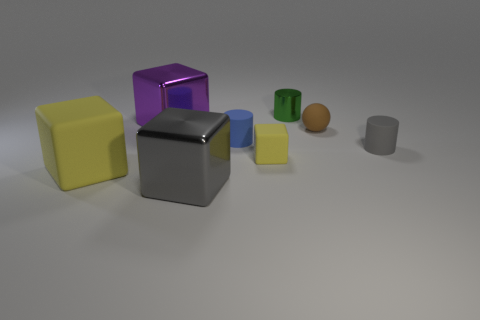Are there any gray metal cubes right of the tiny blue rubber cylinder?
Your answer should be compact. No. What size is the blue matte thing that is the same shape as the small green shiny thing?
Give a very brief answer. Small. There is a small rubber cube; is its color the same as the shiny block in front of the large yellow matte object?
Ensure brevity in your answer.  No. Do the large rubber block and the tiny rubber ball have the same color?
Ensure brevity in your answer.  No. Is the number of small gray rubber things less than the number of large blocks?
Your answer should be compact. Yes. What number of other objects are the same color as the large matte block?
Your answer should be very brief. 1. What number of big red rubber things are there?
Ensure brevity in your answer.  0. Is the number of purple things right of the blue matte cylinder less than the number of tiny gray matte spheres?
Provide a succinct answer. No. Is the gray object that is on the left side of the tiny gray matte thing made of the same material as the green cylinder?
Your answer should be very brief. Yes. What is the shape of the matte thing that is to the left of the metal thing in front of the big metal block behind the small brown matte ball?
Your answer should be compact. Cube. 